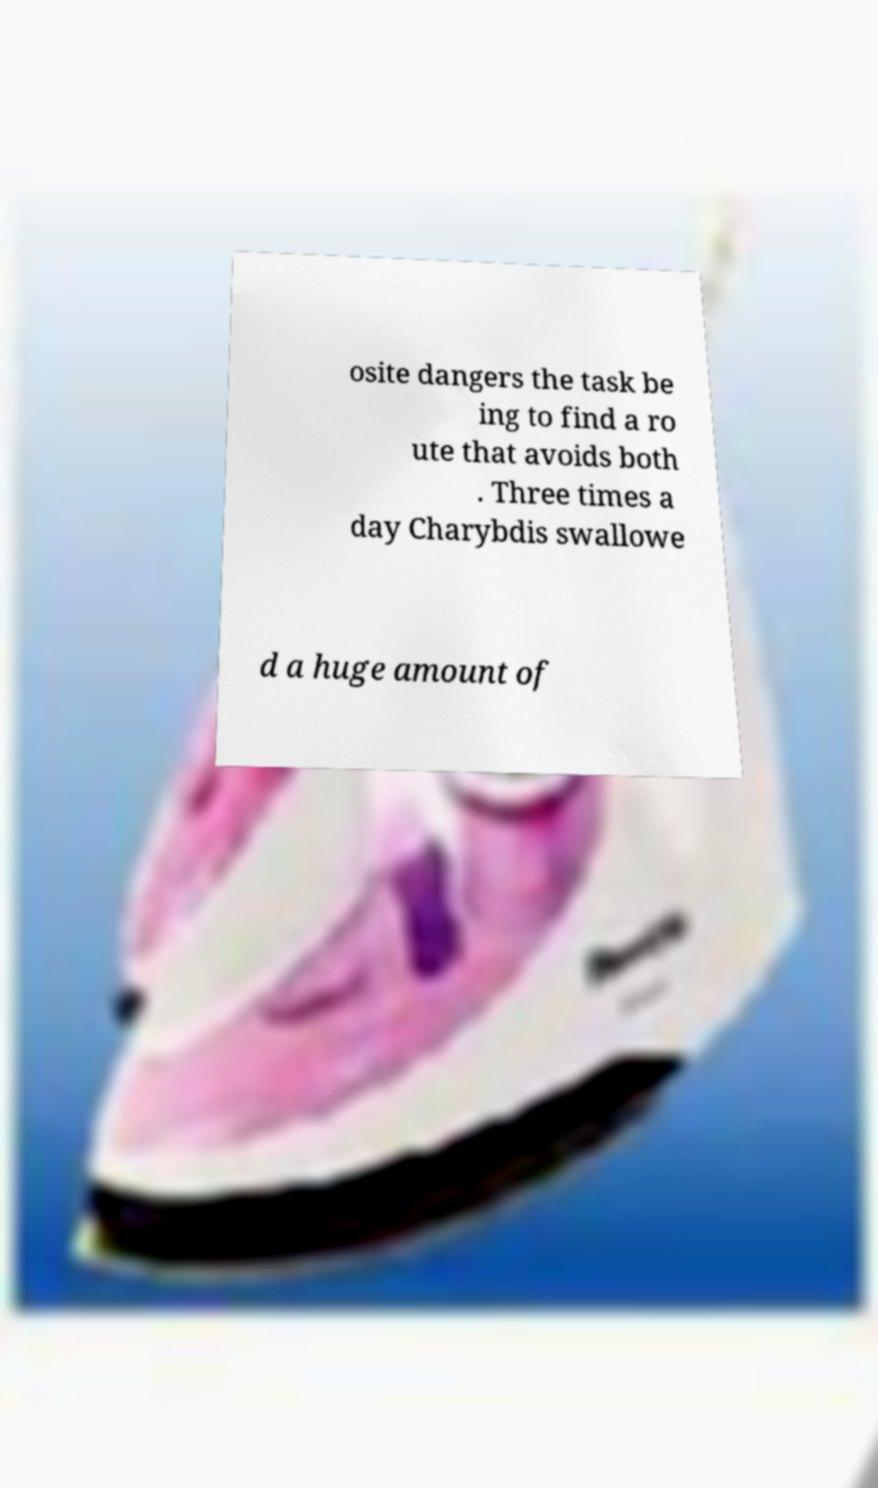Could you extract and type out the text from this image? osite dangers the task be ing to find a ro ute that avoids both . Three times a day Charybdis swallowe d a huge amount of 